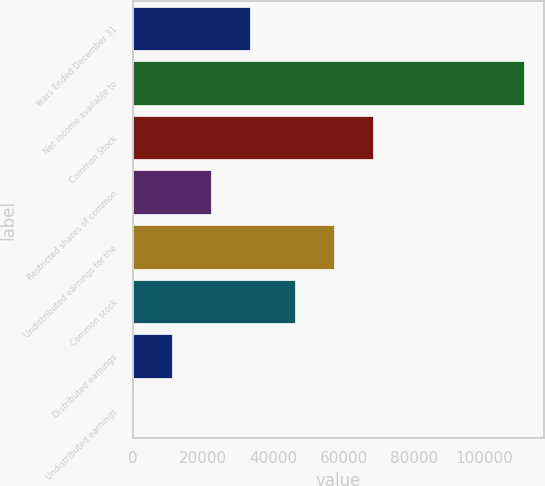<chart> <loc_0><loc_0><loc_500><loc_500><bar_chart><fcel>Years Ended December 31<fcel>Net income available to<fcel>Common Stock<fcel>Restricted shares of common<fcel>Undistributed earnings for the<fcel>Common stock<fcel>Distributed earnings<fcel>Undistributed earnings<nl><fcel>33399.8<fcel>111332<fcel>68416.3<fcel>22266.7<fcel>57283.2<fcel>46150<fcel>11133.5<fcel>0.32<nl></chart> 